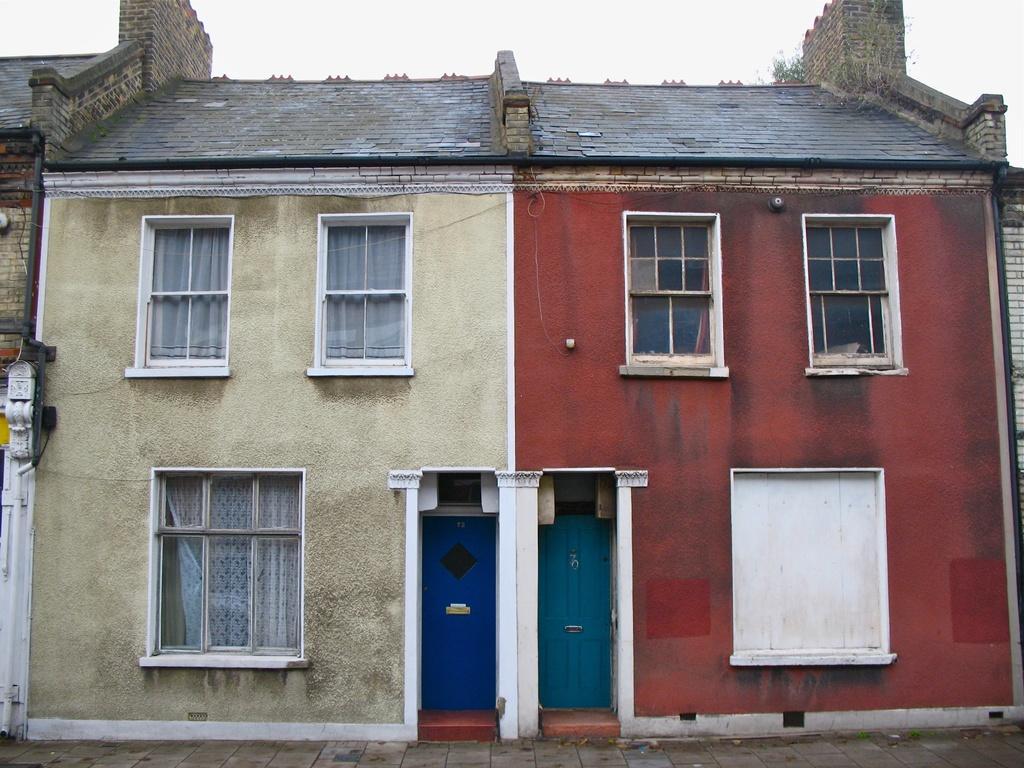Could you give a brief overview of what you see in this image? In this picture, we see a building which is in cream and red color. We see doors in blue color. We even see windows. At the top of the picture, we see the sky. 